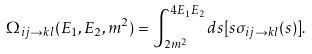Convert formula to latex. <formula><loc_0><loc_0><loc_500><loc_500>\Omega _ { i j \rightarrow k l } ( E _ { 1 } , E _ { 2 } , m ^ { 2 } ) = \int _ { 2 m ^ { 2 } } ^ { 4 E _ { 1 } E _ { 2 } } d s [ s \sigma _ { i j \rightarrow k l } ( s ) ] .</formula> 